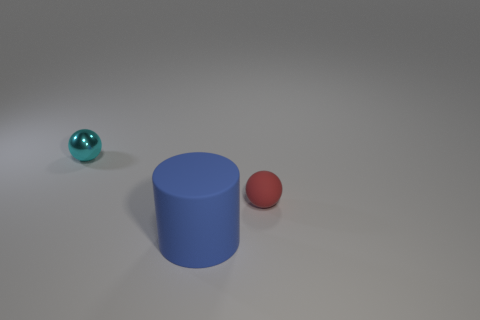Are there fewer blue rubber things that are to the right of the big cylinder than tiny green metallic cubes?
Keep it short and to the point. No. Does the rubber cylinder have the same color as the metallic ball?
Make the answer very short. No. What is the size of the rubber thing that is the same shape as the small cyan shiny object?
Your answer should be very brief. Small. How many red things are the same material as the big cylinder?
Offer a very short reply. 1. Are the tiny sphere on the left side of the blue thing and the large cylinder made of the same material?
Ensure brevity in your answer.  No. Is the number of red matte objects in front of the rubber ball the same as the number of big blue matte cylinders?
Make the answer very short. No. The red rubber thing is what size?
Your answer should be compact. Small. Is the size of the blue matte object the same as the shiny thing?
Your answer should be compact. No. How big is the rubber object that is behind the thing that is in front of the tiny red sphere?
Provide a short and direct response. Small. Do the big thing and the ball on the right side of the tiny metal ball have the same color?
Make the answer very short. No. 